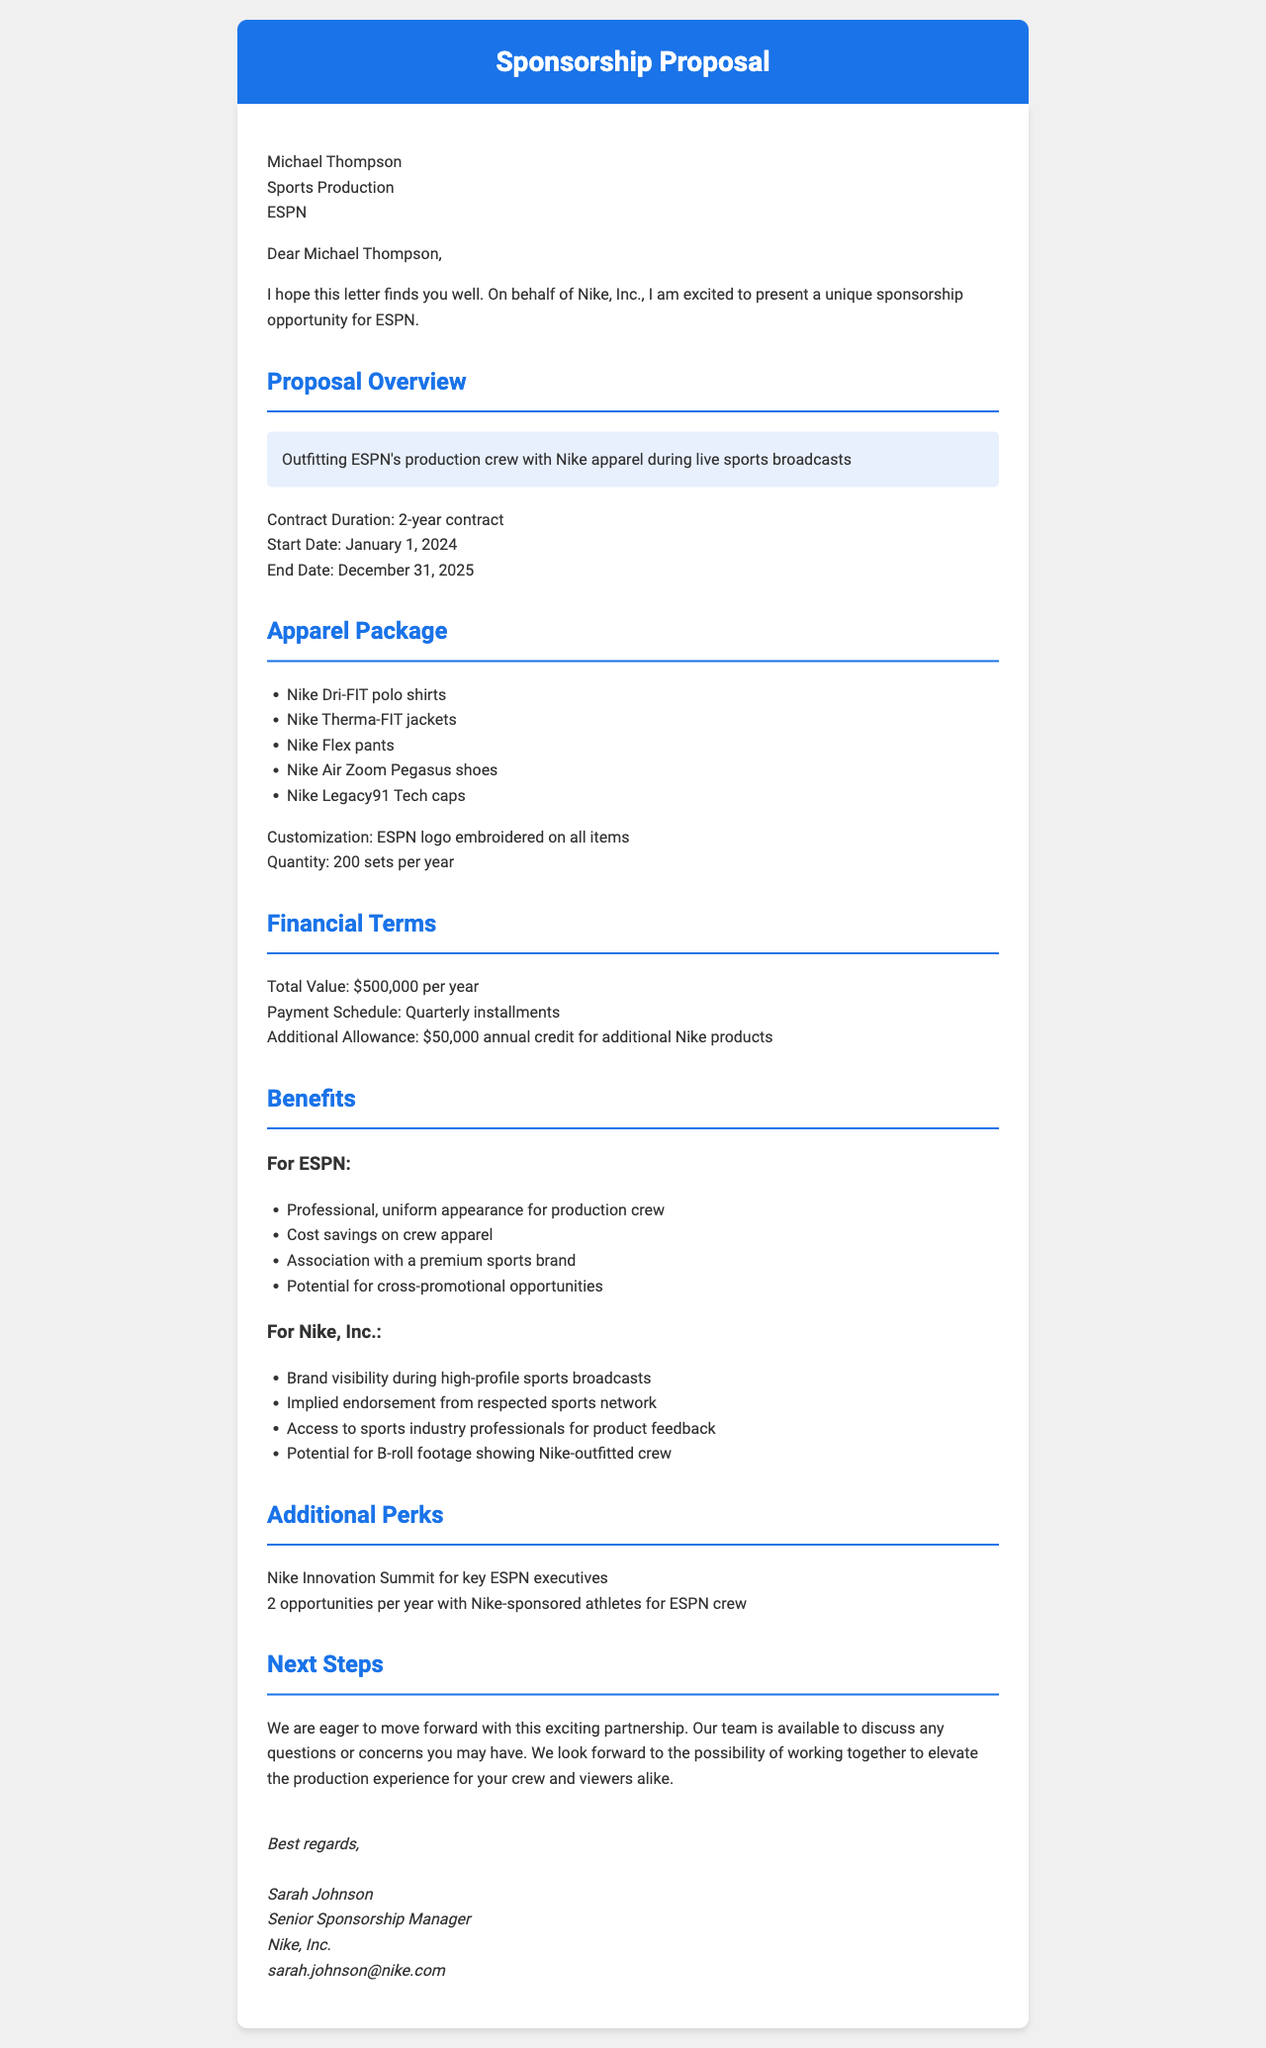What is the name of the sender company? The sender company is identified in the document as Nike, Inc.
Answer: Nike, Inc Who is the representative of the sender? The representative's name is provided in the document.
Answer: Sarah Johnson What is the duration of the contract? The duration of the contract is specified in the proposal details.
Answer: 2-year contract When does the contract start? The start date is mentioned in the proposal details section.
Answer: January 1, 2024 What is the total annual value of the sponsorship? The total value is explicitly stated in the financial terms section of the document.
Answer: $500,000 per year What benefit is mentioned for ESPN regarding crew appearance? This benefit refers to the professional look provided by the apparel.
Answer: Professional, uniform appearance for production crew How many annual meet and greets are included with sponsored athletes? The number of opportunities for athlete meet and greets is indicated in the additional perks section.
Answer: 2 opportunities per year What is required for early termination of the contract by either party? The legal considerations section specifies the notice period required for early termination.
Answer: 90-day notice What marketing collaboration strategy is proposed? The document highlights a joint marketing campaign as part of the collaboration.
Answer: Joint #BehindTheScenes campaign 